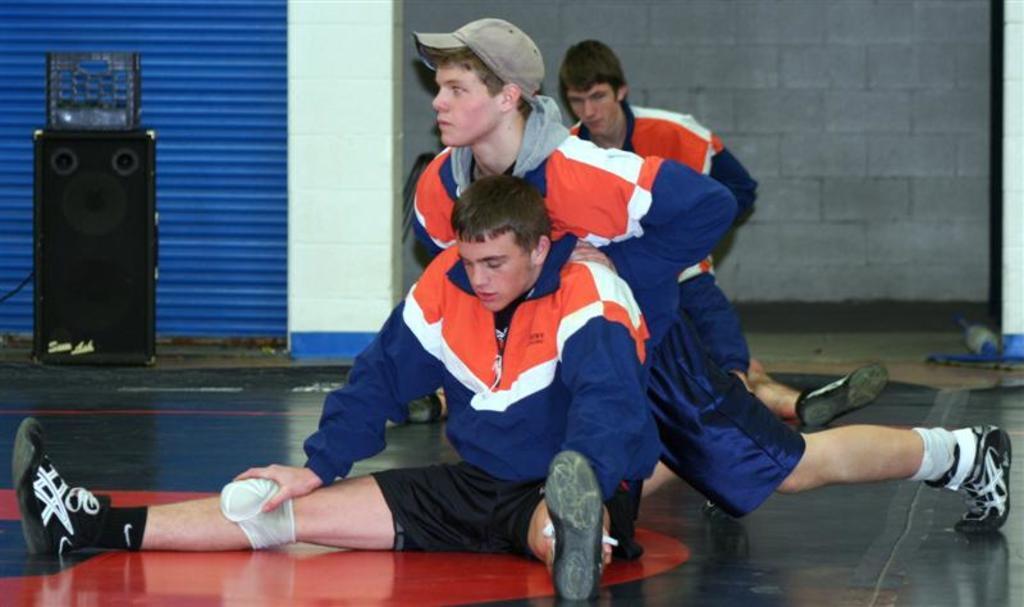In one or two sentences, can you explain what this image depicts? In this image there is a man sitting on the floor by stretching his legs. In the background there is another person who is pushing the man who is sitting on the ground. On the left side there are speakers. In the background there is a wall. Beside the wall there is a shutter. In the background there are two other persons. 